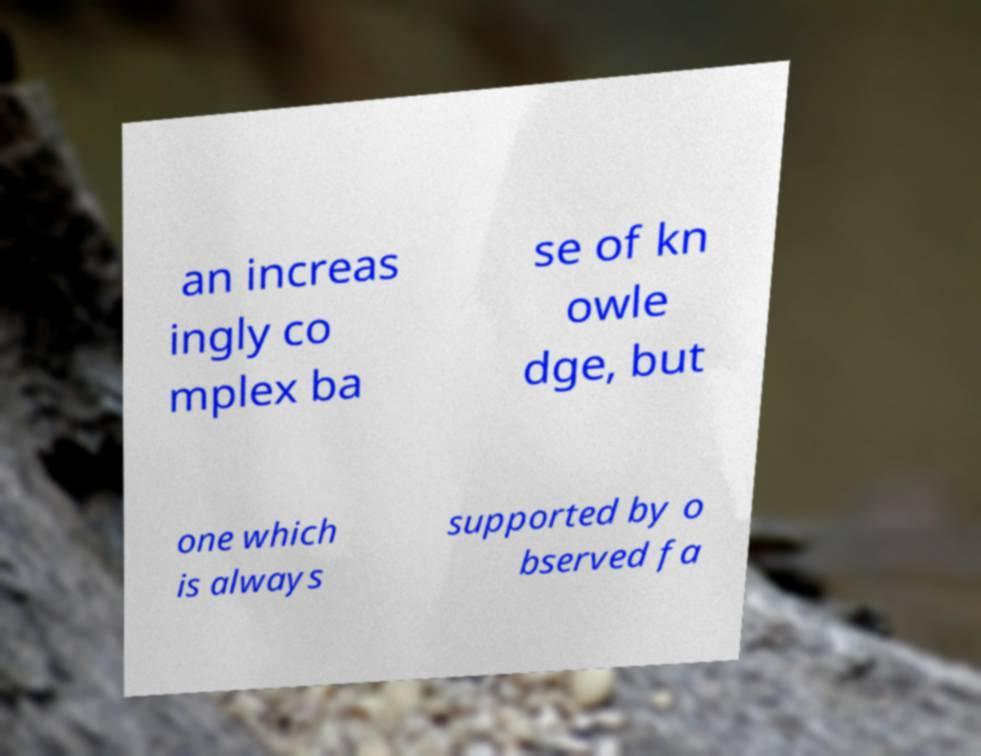Could you extract and type out the text from this image? an increas ingly co mplex ba se of kn owle dge, but one which is always supported by o bserved fa 